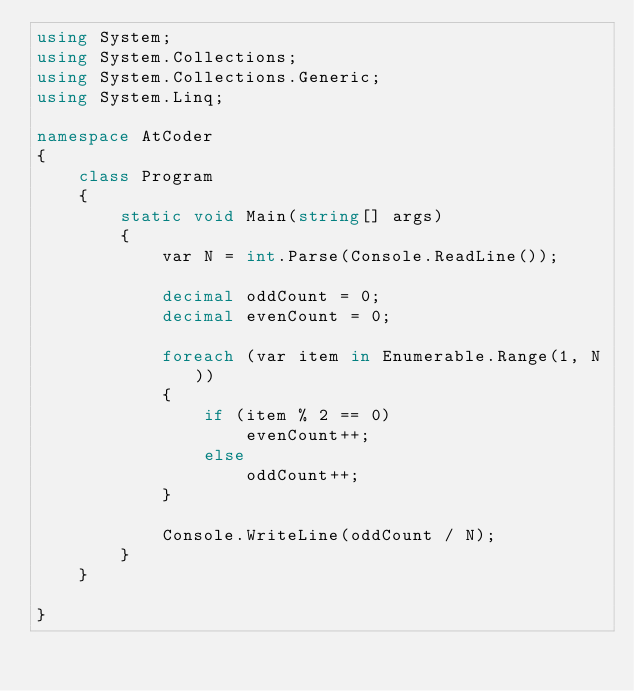<code> <loc_0><loc_0><loc_500><loc_500><_C#_>using System;
using System.Collections;
using System.Collections.Generic;
using System.Linq;

namespace AtCoder
{
    class Program
    {
        static void Main(string[] args)
        {
            var N = int.Parse(Console.ReadLine());

            decimal oddCount = 0;
            decimal evenCount = 0;

            foreach (var item in Enumerable.Range(1, N))
            {
                if (item % 2 == 0)
                    evenCount++;
                else
                    oddCount++;
            }

            Console.WriteLine(oddCount / N);
        }
    }

}
</code> 